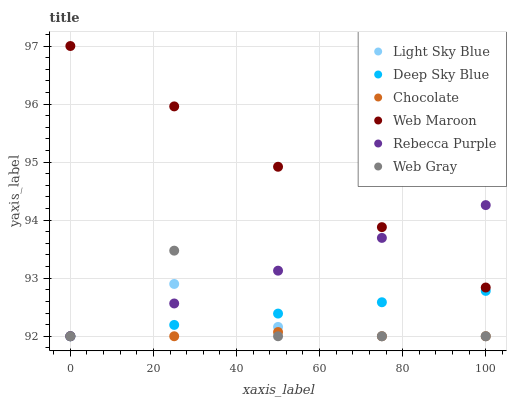Does Chocolate have the minimum area under the curve?
Answer yes or no. Yes. Does Web Maroon have the maximum area under the curve?
Answer yes or no. Yes. Does Web Maroon have the minimum area under the curve?
Answer yes or no. No. Does Chocolate have the maximum area under the curve?
Answer yes or no. No. Is Web Maroon the smoothest?
Answer yes or no. Yes. Is Web Gray the roughest?
Answer yes or no. Yes. Is Chocolate the smoothest?
Answer yes or no. No. Is Chocolate the roughest?
Answer yes or no. No. Does Web Gray have the lowest value?
Answer yes or no. Yes. Does Web Maroon have the lowest value?
Answer yes or no. No. Does Web Maroon have the highest value?
Answer yes or no. Yes. Does Chocolate have the highest value?
Answer yes or no. No. Is Deep Sky Blue less than Web Maroon?
Answer yes or no. Yes. Is Web Maroon greater than Web Gray?
Answer yes or no. Yes. Does Rebecca Purple intersect Deep Sky Blue?
Answer yes or no. Yes. Is Rebecca Purple less than Deep Sky Blue?
Answer yes or no. No. Is Rebecca Purple greater than Deep Sky Blue?
Answer yes or no. No. Does Deep Sky Blue intersect Web Maroon?
Answer yes or no. No. 